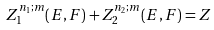Convert formula to latex. <formula><loc_0><loc_0><loc_500><loc_500>Z _ { 1 } ^ { n _ { 1 } ; m } ( E , F ) + Z _ { 2 } ^ { n _ { 2 } ; m } ( E , F ) = Z</formula> 